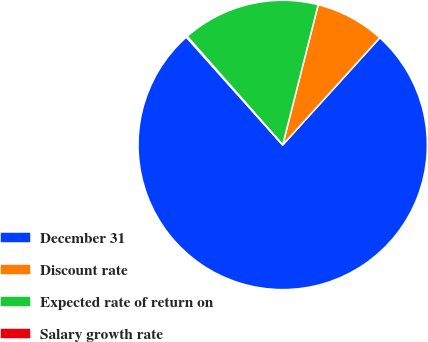Convert chart to OTSL. <chart><loc_0><loc_0><loc_500><loc_500><pie_chart><fcel>December 31<fcel>Discount rate<fcel>Expected rate of return on<fcel>Salary growth rate<nl><fcel>76.68%<fcel>7.77%<fcel>15.43%<fcel>0.12%<nl></chart> 